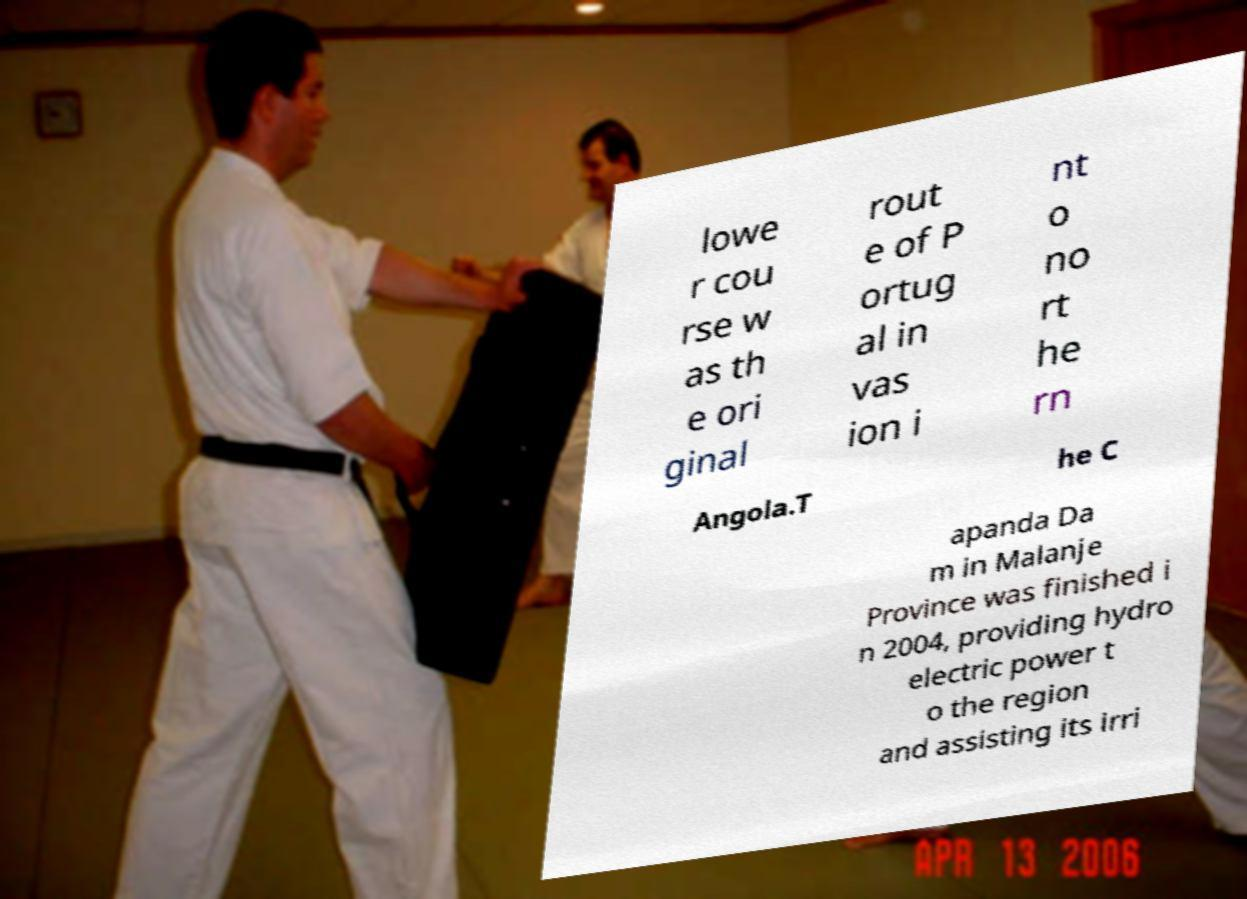For documentation purposes, I need the text within this image transcribed. Could you provide that? lowe r cou rse w as th e ori ginal rout e of P ortug al in vas ion i nt o no rt he rn Angola.T he C apanda Da m in Malanje Province was finished i n 2004, providing hydro electric power t o the region and assisting its irri 